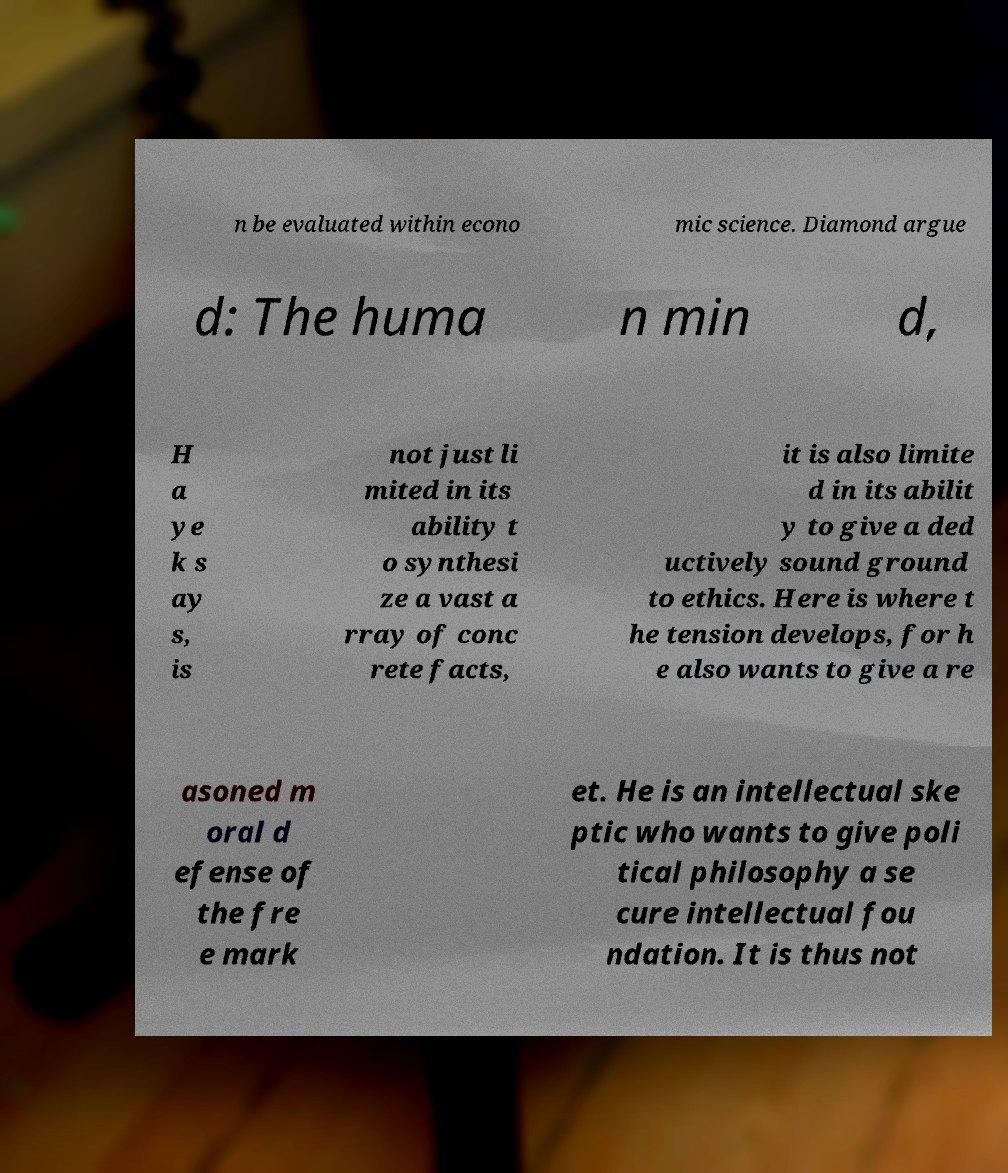Could you assist in decoding the text presented in this image and type it out clearly? n be evaluated within econo mic science. Diamond argue d: The huma n min d, H a ye k s ay s, is not just li mited in its ability t o synthesi ze a vast a rray of conc rete facts, it is also limite d in its abilit y to give a ded uctively sound ground to ethics. Here is where t he tension develops, for h e also wants to give a re asoned m oral d efense of the fre e mark et. He is an intellectual ske ptic who wants to give poli tical philosophy a se cure intellectual fou ndation. It is thus not 